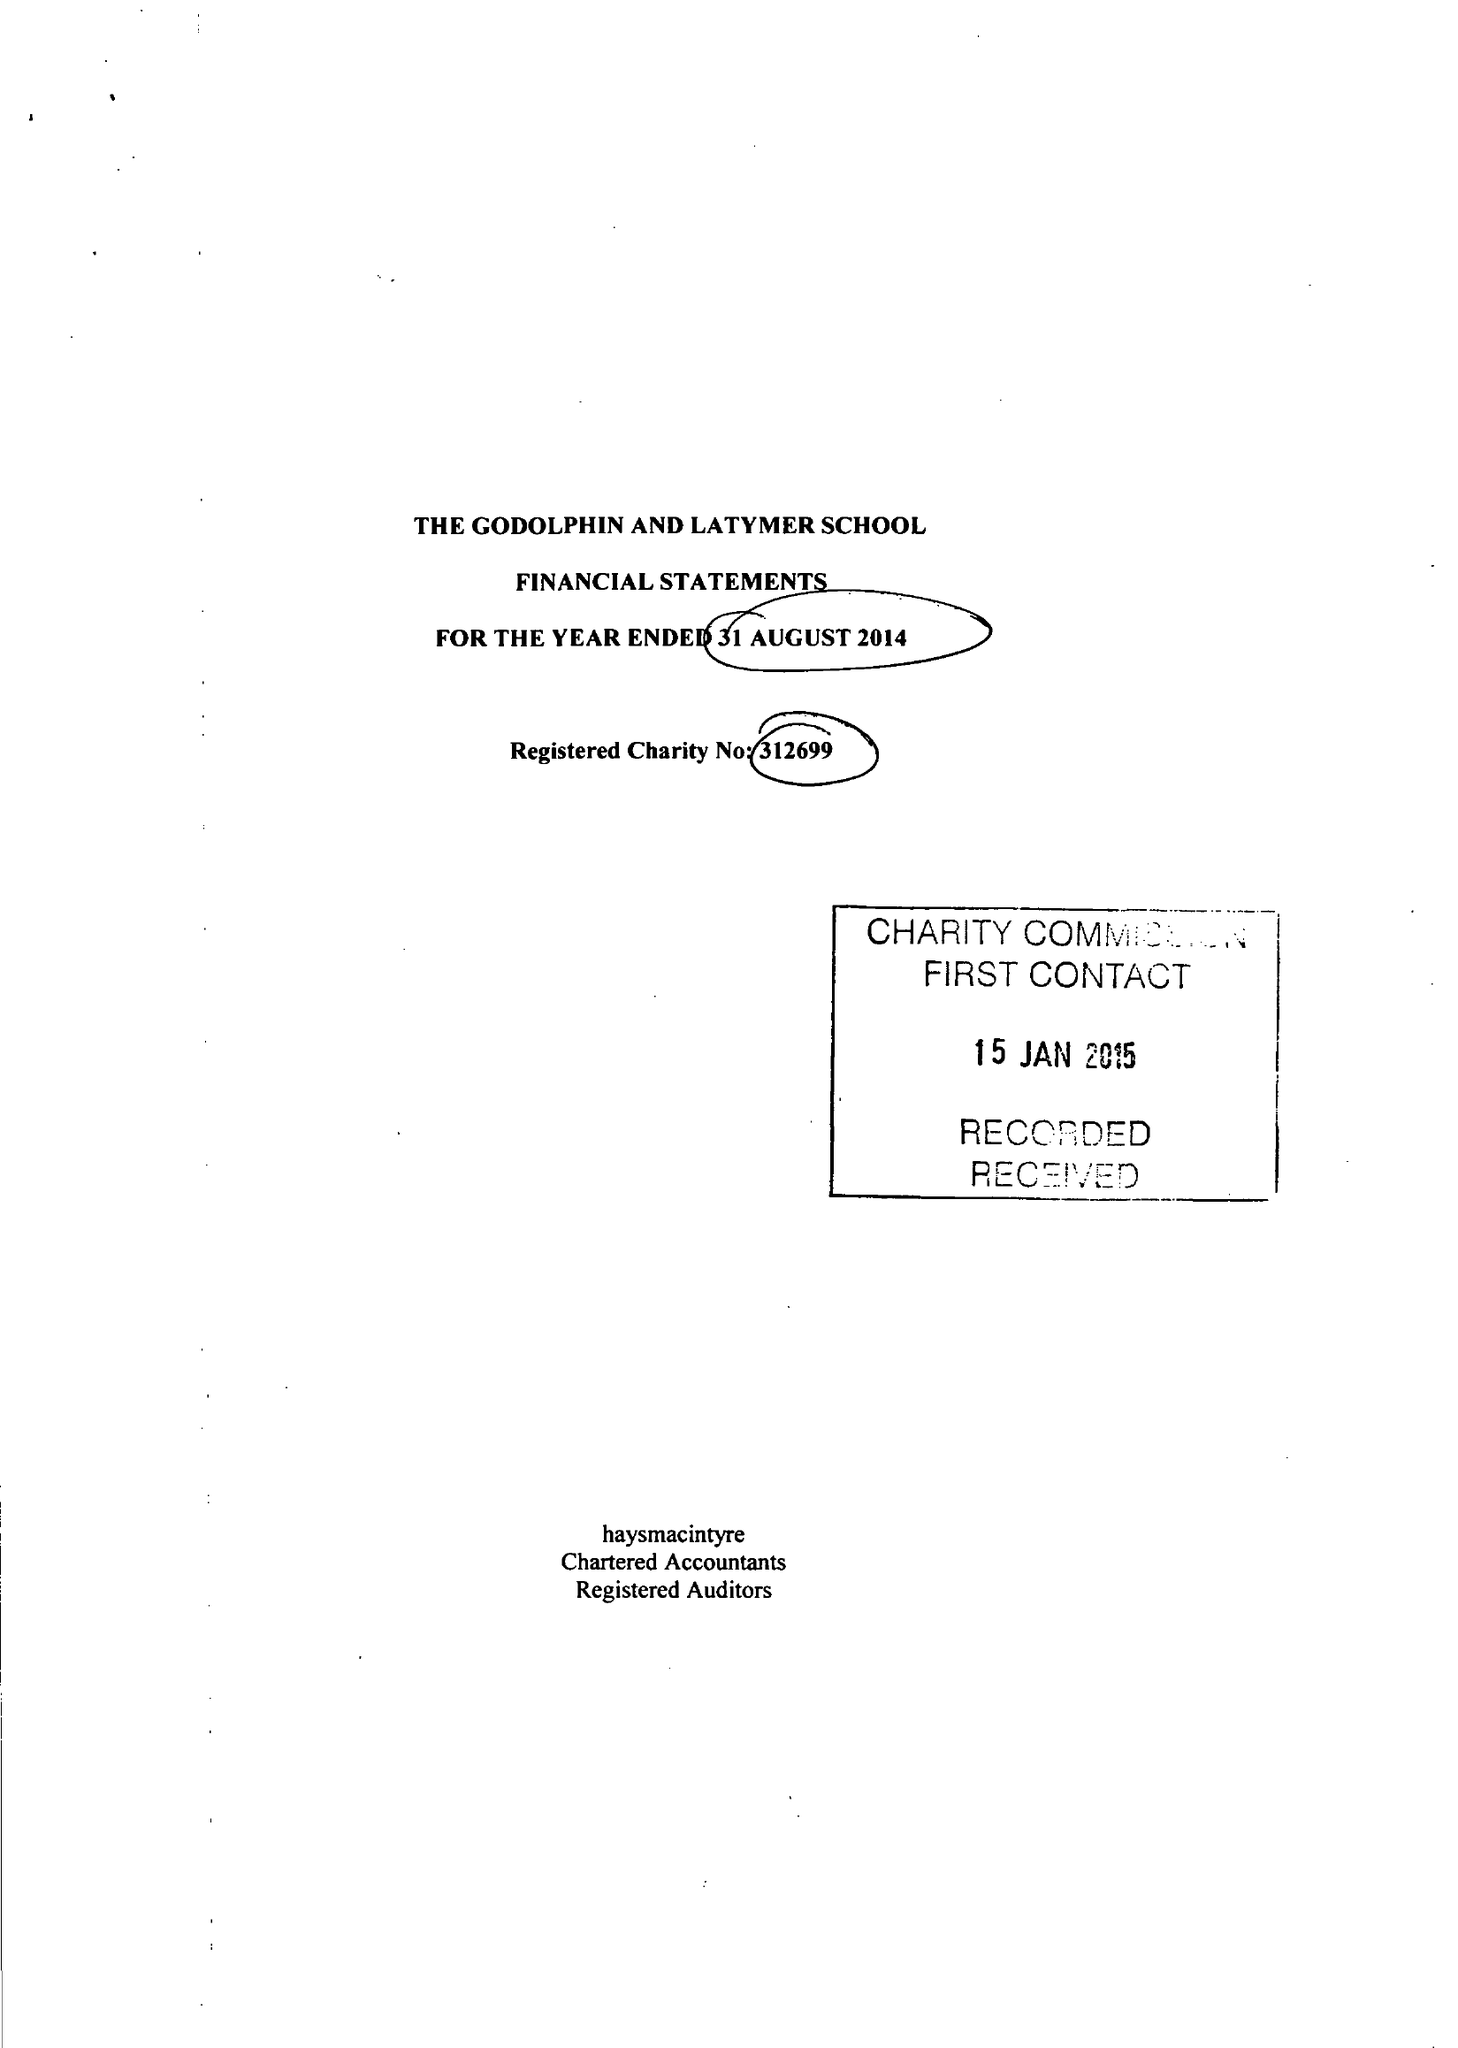What is the value for the report_date?
Answer the question using a single word or phrase. 2014-08-31 